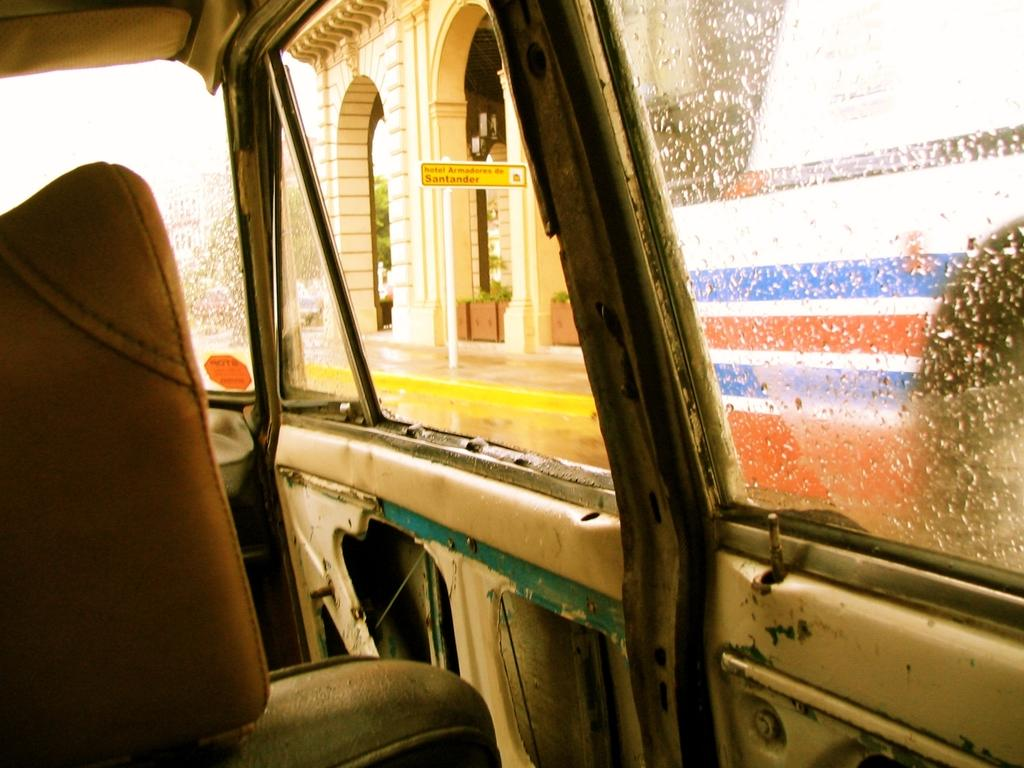What is the main subject of the image? There is a vehicle in the image. What can be seen from the vehicle in the image? A building is visible from the vehicle in the image. What is the condition of the mirror in the vehicle? There are water drops on the mirror in the vehicle. How many dimes can be seen on the coach in the image? There is no coach or dimes present in the image. What type of waste is visible in the image? There is no waste visible in the image; it features a vehicle with a building in the background and a mirror with water drops. 